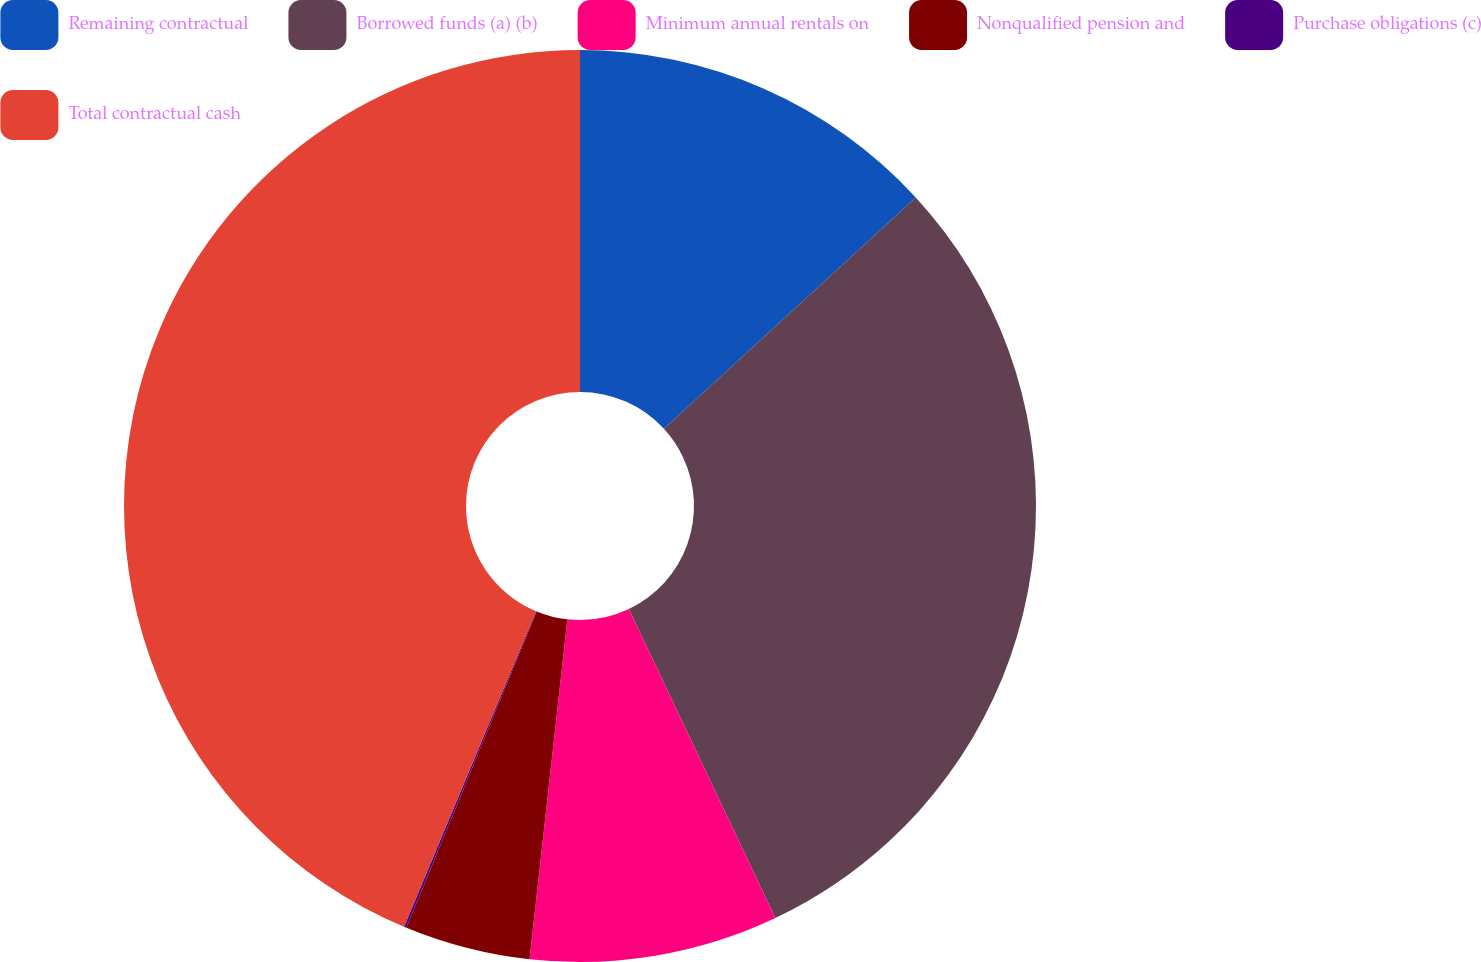Convert chart to OTSL. <chart><loc_0><loc_0><loc_500><loc_500><pie_chart><fcel>Remaining contractual<fcel>Borrowed funds (a) (b)<fcel>Minimum annual rentals on<fcel>Nonqualified pension and<fcel>Purchase obligations (c)<fcel>Total contractual cash<nl><fcel>13.17%<fcel>29.78%<fcel>8.81%<fcel>4.45%<fcel>0.09%<fcel>43.69%<nl></chart> 